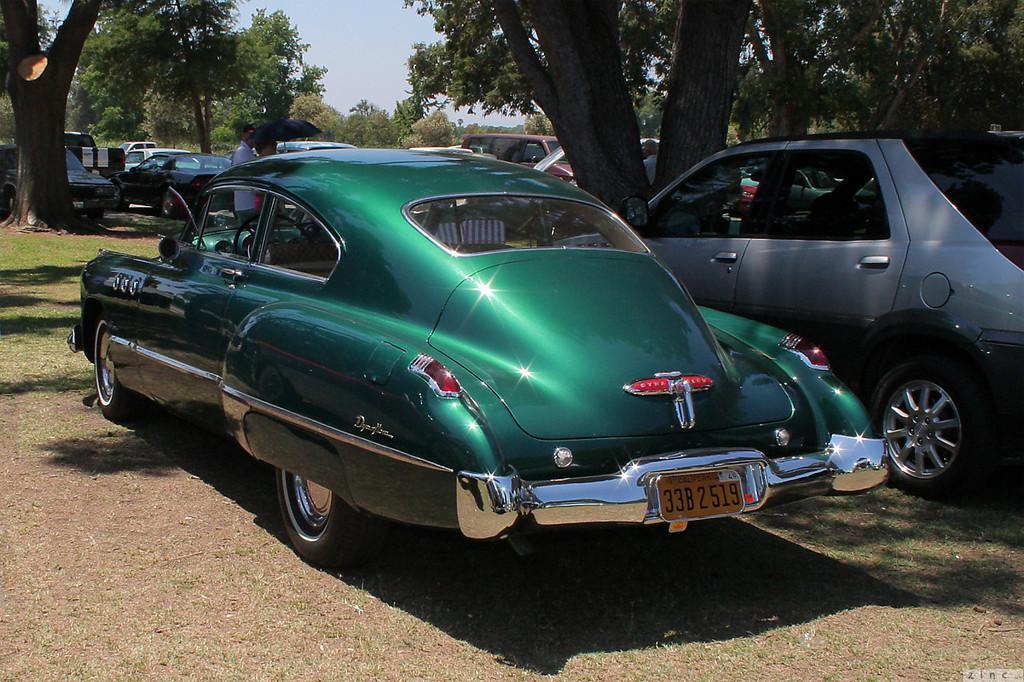Please provide a concise description of this image. The picture consists of cars, trees, grass and people. In the center of the picture there is a person holding an umbrella. It is sunny. 